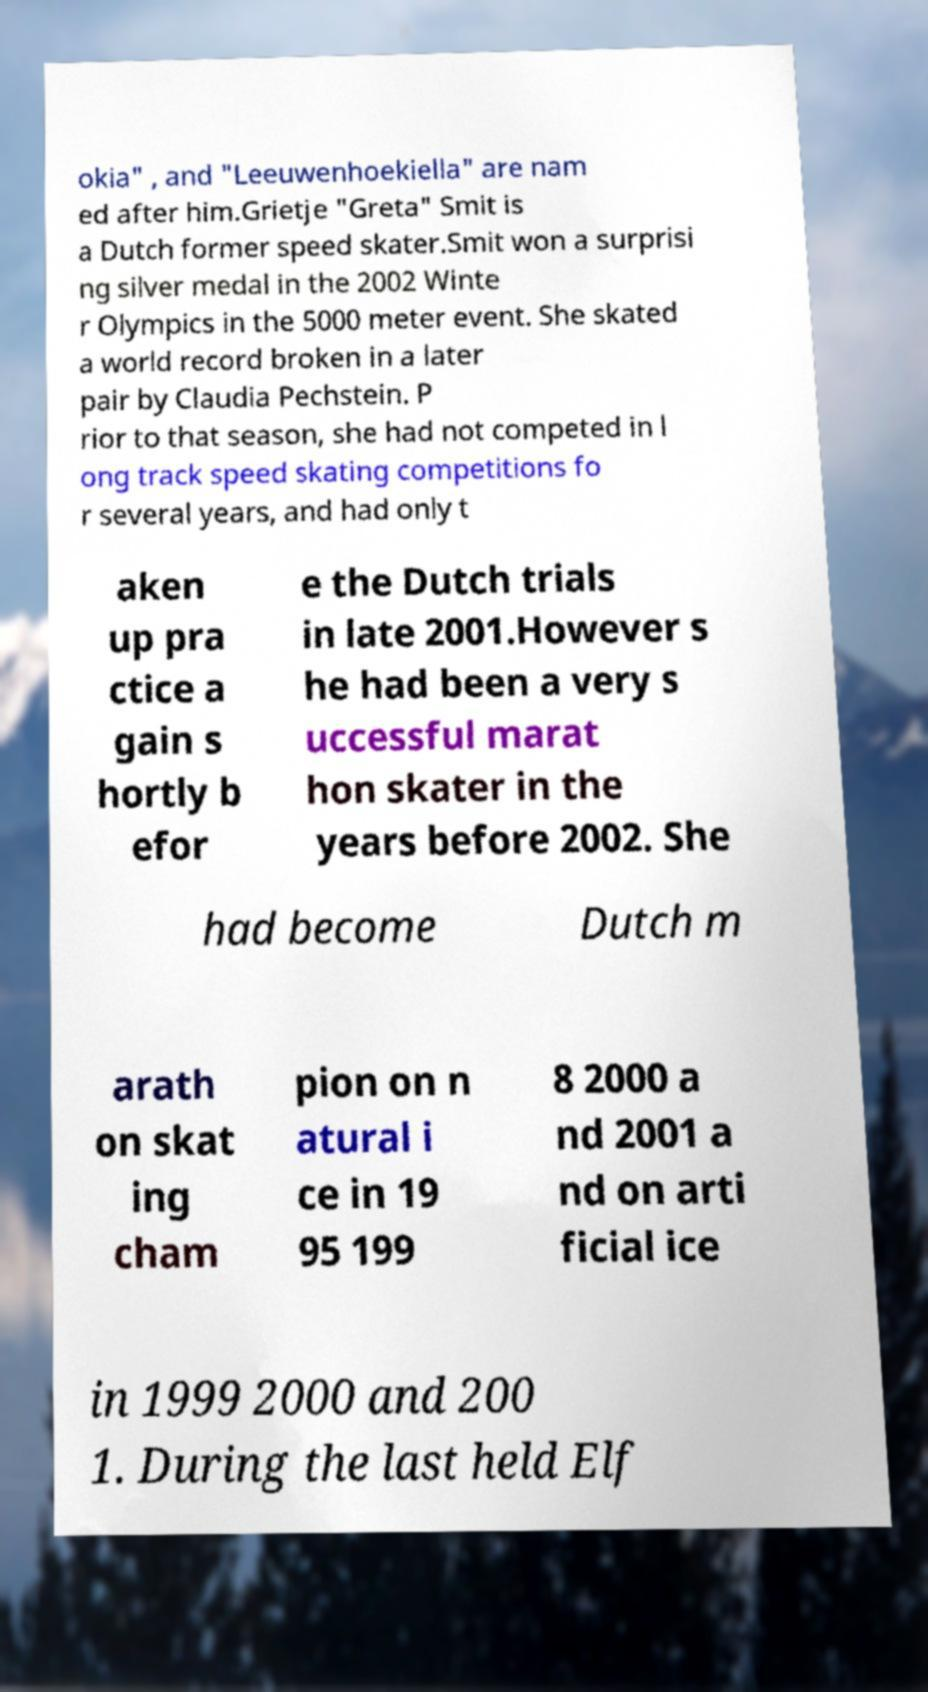I need the written content from this picture converted into text. Can you do that? okia" , and "Leeuwenhoekiella" are nam ed after him.Grietje "Greta" Smit is a Dutch former speed skater.Smit won a surprisi ng silver medal in the 2002 Winte r Olympics in the 5000 meter event. She skated a world record broken in a later pair by Claudia Pechstein. P rior to that season, she had not competed in l ong track speed skating competitions fo r several years, and had only t aken up pra ctice a gain s hortly b efor e the Dutch trials in late 2001.However s he had been a very s uccessful marat hon skater in the years before 2002. She had become Dutch m arath on skat ing cham pion on n atural i ce in 19 95 199 8 2000 a nd 2001 a nd on arti ficial ice in 1999 2000 and 200 1. During the last held Elf 